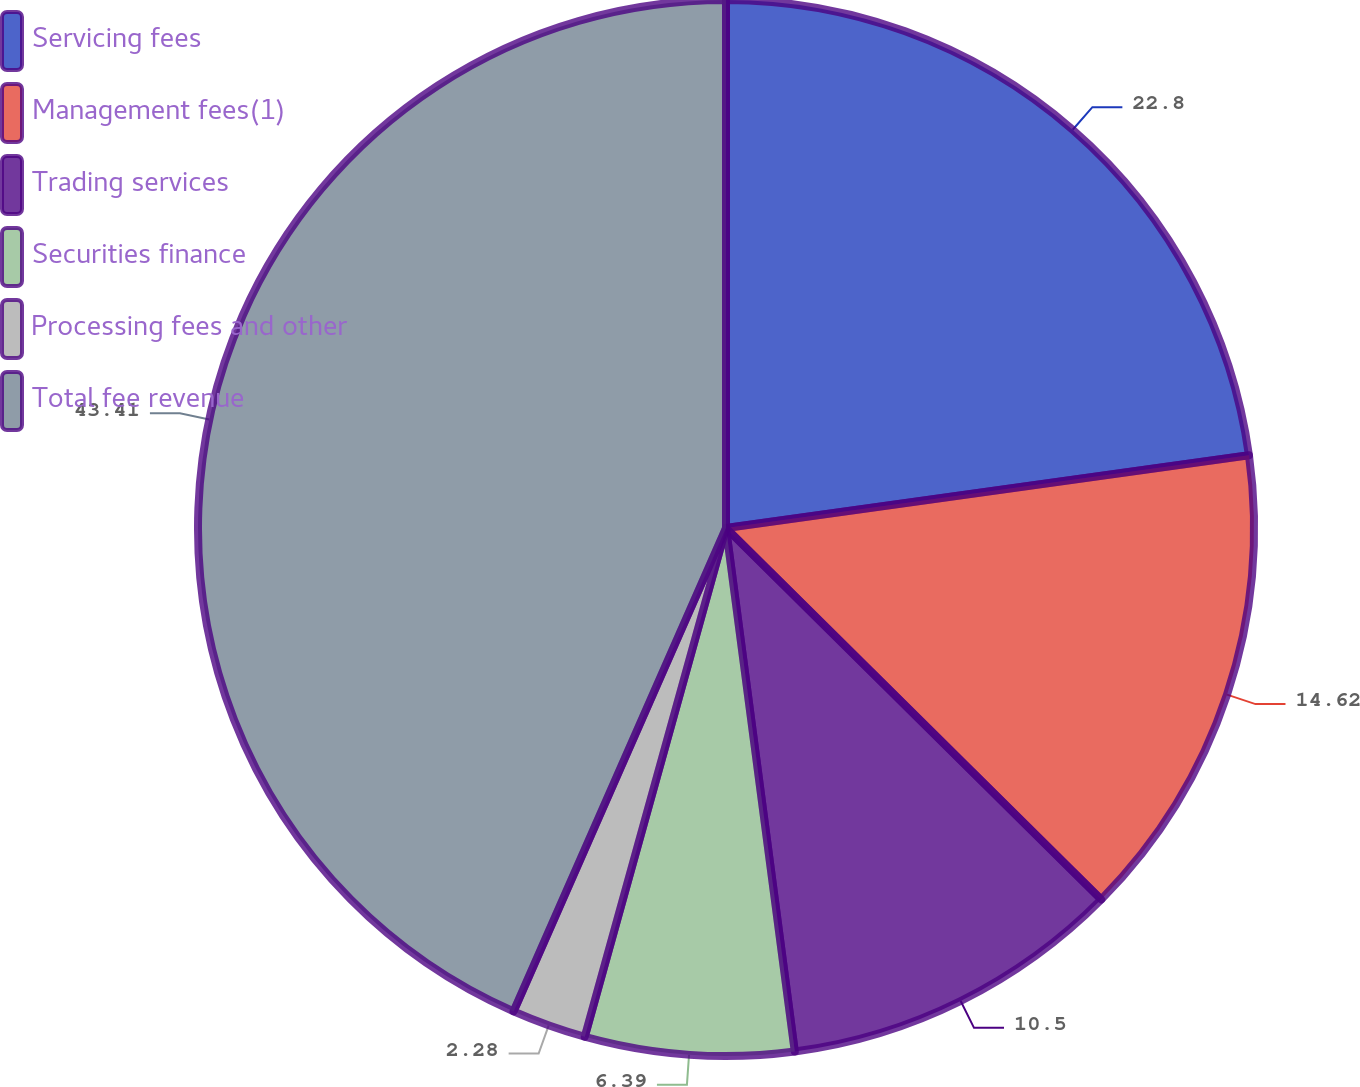Convert chart. <chart><loc_0><loc_0><loc_500><loc_500><pie_chart><fcel>Servicing fees<fcel>Management fees(1)<fcel>Trading services<fcel>Securities finance<fcel>Processing fees and other<fcel>Total fee revenue<nl><fcel>22.8%<fcel>14.62%<fcel>10.5%<fcel>6.39%<fcel>2.28%<fcel>43.41%<nl></chart> 